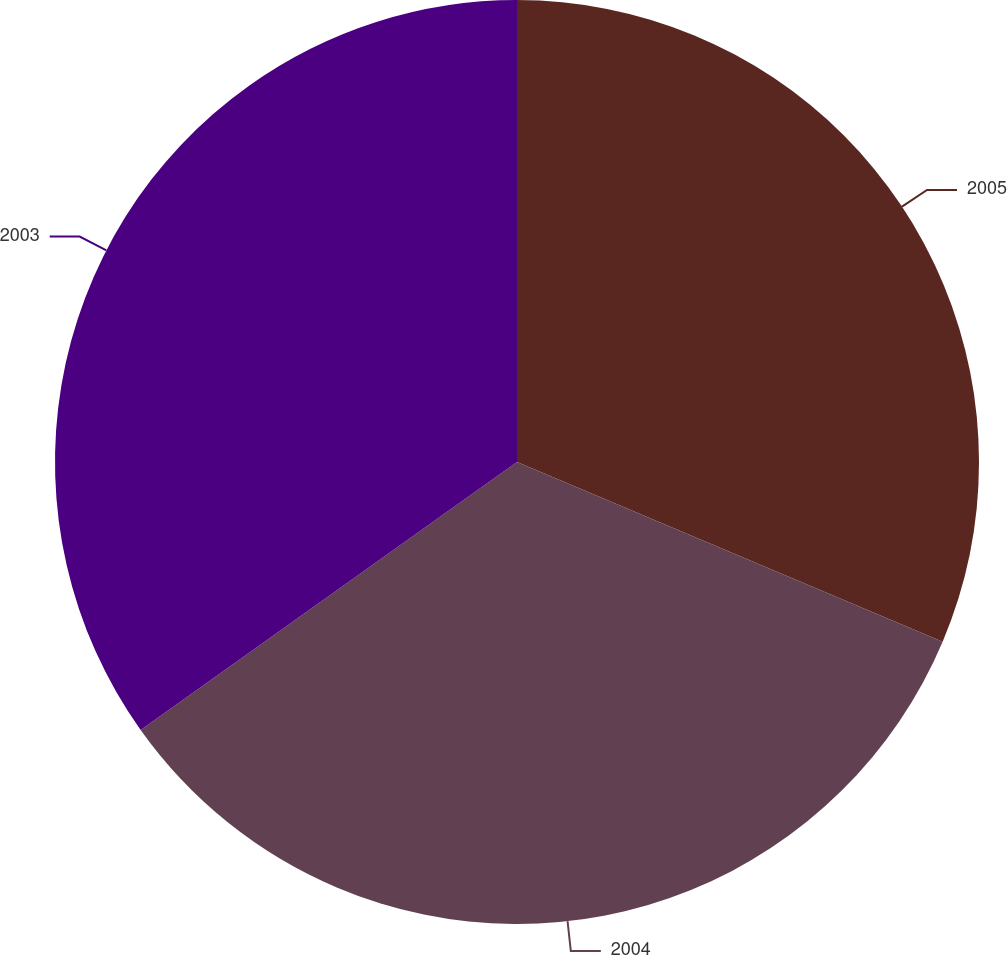Convert chart to OTSL. <chart><loc_0><loc_0><loc_500><loc_500><pie_chart><fcel>2005<fcel>2004<fcel>2003<nl><fcel>31.36%<fcel>33.8%<fcel>34.85%<nl></chart> 